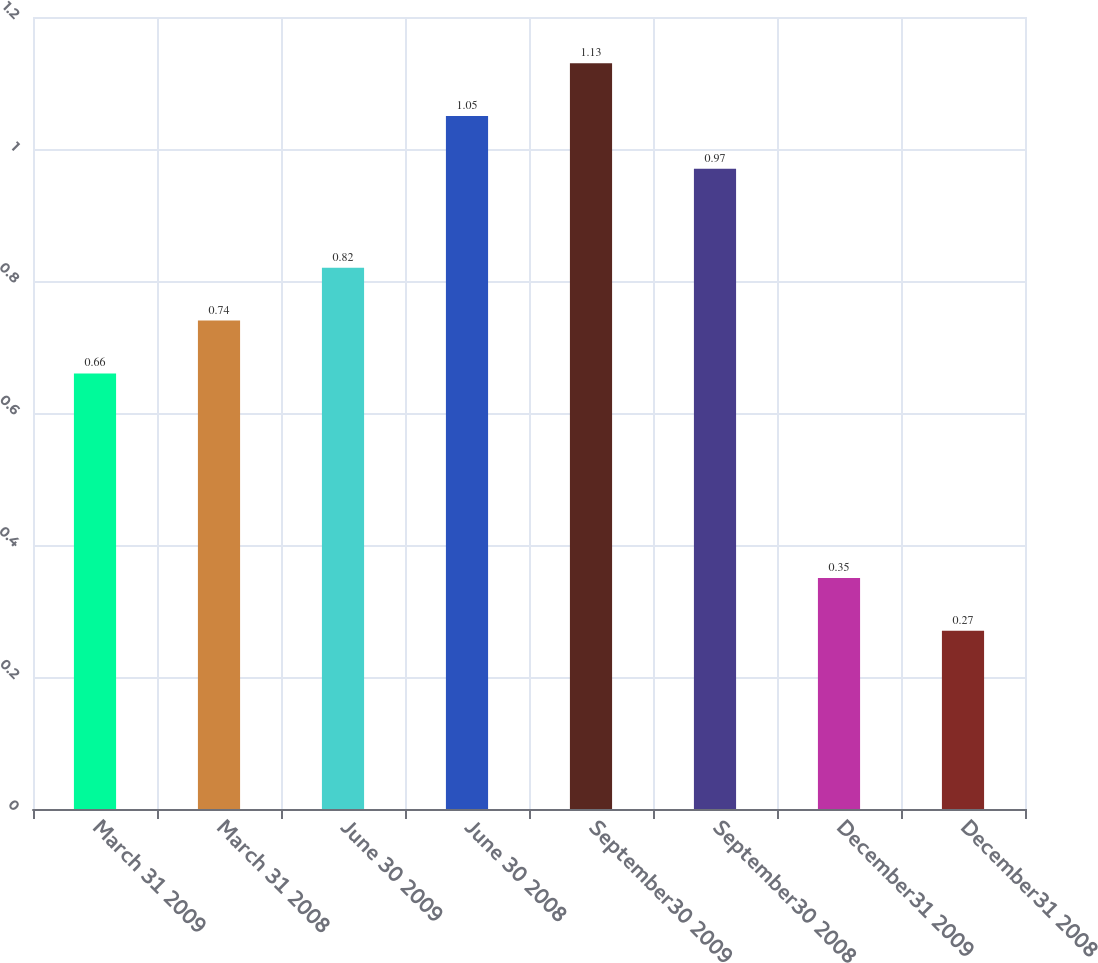Convert chart to OTSL. <chart><loc_0><loc_0><loc_500><loc_500><bar_chart><fcel>March 31 2009<fcel>March 31 2008<fcel>June 30 2009<fcel>June 30 2008<fcel>September30 2009<fcel>September30 2008<fcel>December31 2009<fcel>December31 2008<nl><fcel>0.66<fcel>0.74<fcel>0.82<fcel>1.05<fcel>1.13<fcel>0.97<fcel>0.35<fcel>0.27<nl></chart> 